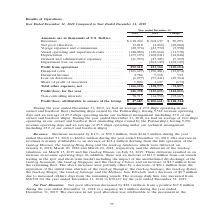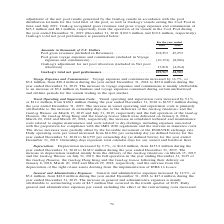From Gaslog's financial document, In which years was the total net pool performance recorded for? The document shows two values: 2018 and 2019. From the document: "mber 31, 2018 Compared to Year Ended December 31, 2019 Year Ended December 31, 2018 Compared to Year Ended December 31, 2019..." Also, What accounted for the decrease in net pool allocation? Based on the financial document, the answer is The decrease in net pool allocation was attributable to the movement in the adjustment of the net pool results generated by the GasLog vessels in accordance with the pool distribution formula for the total fleet of the pool, as well as GasLog’s vessels exiting the Cool Pool in June and July 2019. Also, What accounted for the increase in voyage expenses and commissions? Mainly attributable to an increase of $3.4 million in bunkers and voyage expenses consumed during certain unchartered and off-hire periods for the vessels trading in the spot market.. The document states: "The increase in voyage expenses and commissions is mainly attributable to an increase of $3.4 million in bunkers and voyage expenses consumed during c..." Additionally, Which year was the pool gross revenues higher? According to the financial document, 2018. The relevant text states: "Year Ended December 31, 2018 Compared to Year Ended December 31, 2019..." Also, can you calculate: What is the change in pool gross revenues from 2018 to 2019? Based on the calculation: 45,253 - 102,253 , the result is -57000 (in thousands). This is based on the information: "lars Pool gross revenues (included in Revenues) . 102,253 45,253 Pool gross voyage expenses and commissions (included in Voyage expenses and commissions) . ( l gross revenues (included in Revenues) . ..." The key data points involved are: 102,253, 45,253. Also, can you calculate: What is the percentage change in total net pool performance from 2018 to 2019? To answer this question, I need to perform calculations using the financial data. The calculation is: (32,903 - 109,917)/109,917 , which equals -70.07 (percentage). This is based on the information: "GasLog’s total net pool performance . 109,917 32,903 GasLog’s total net pool performance . 109,917 32,903..." The key data points involved are: 109,917, 32,903. 